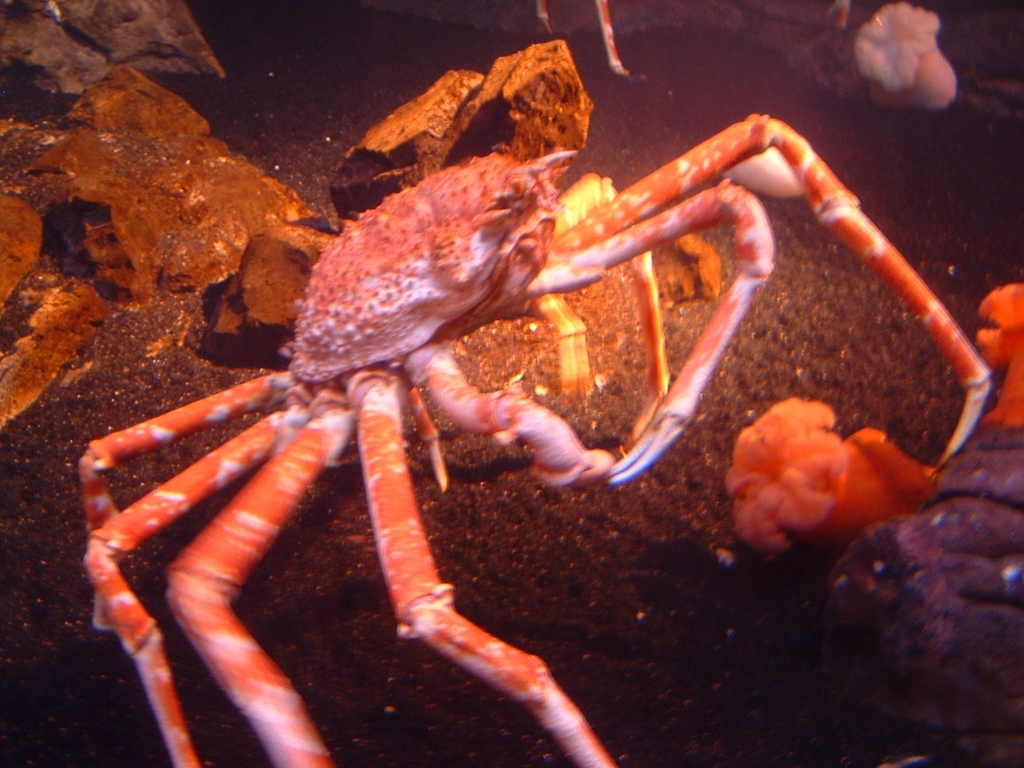Could this image be taken at an aquarium? Given the composition of the image, including elements such as the uniform lighting, the clarity of the water, and the visible layout of rocks and sea life, it does suggest a controlled environment like an aquarium. In natural settings, it's less common to have such clear visibility and such an arrangement of elements without any debris or sediment, which are typically stirred up by currents and marine animal activity. 